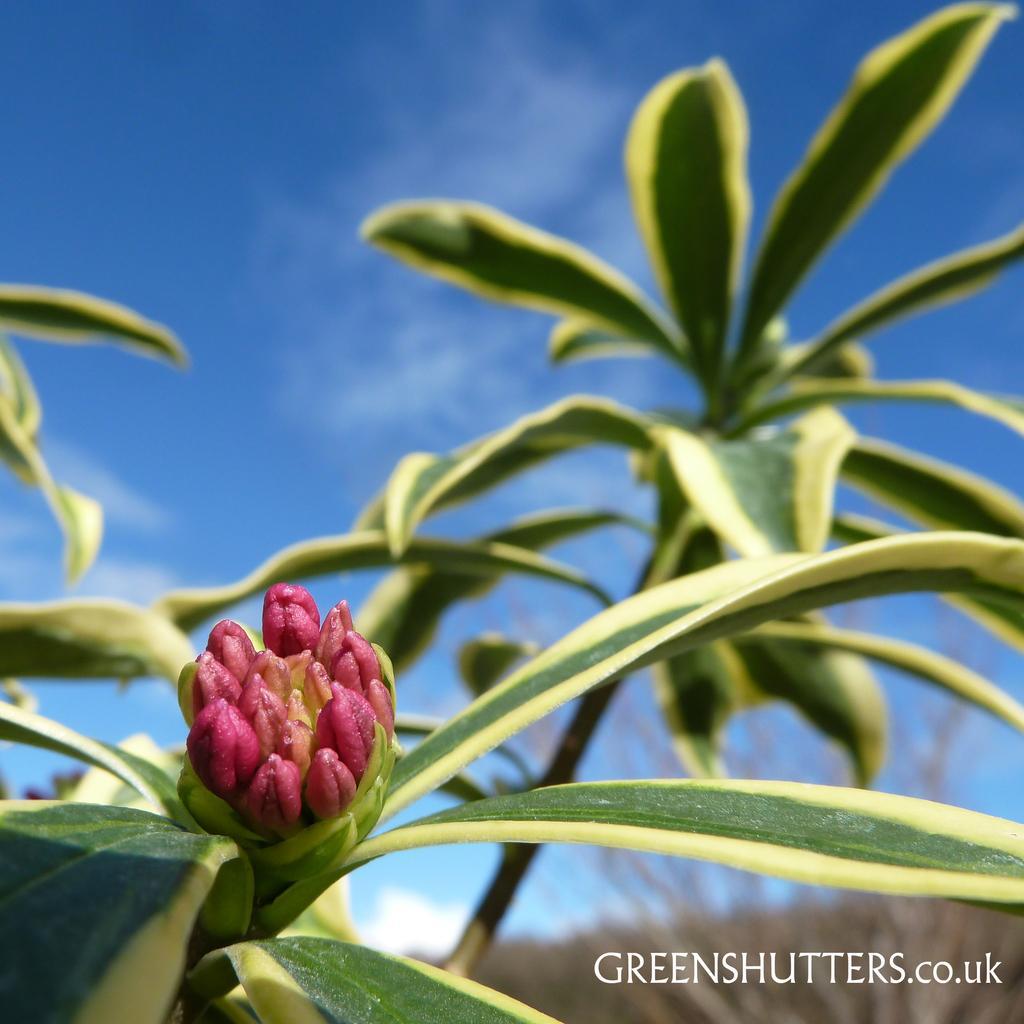Could you give a brief overview of what you see in this image? In this image we can see some plants with some leaves and a bud. On the backside we can see the sky which looks cloudy. 